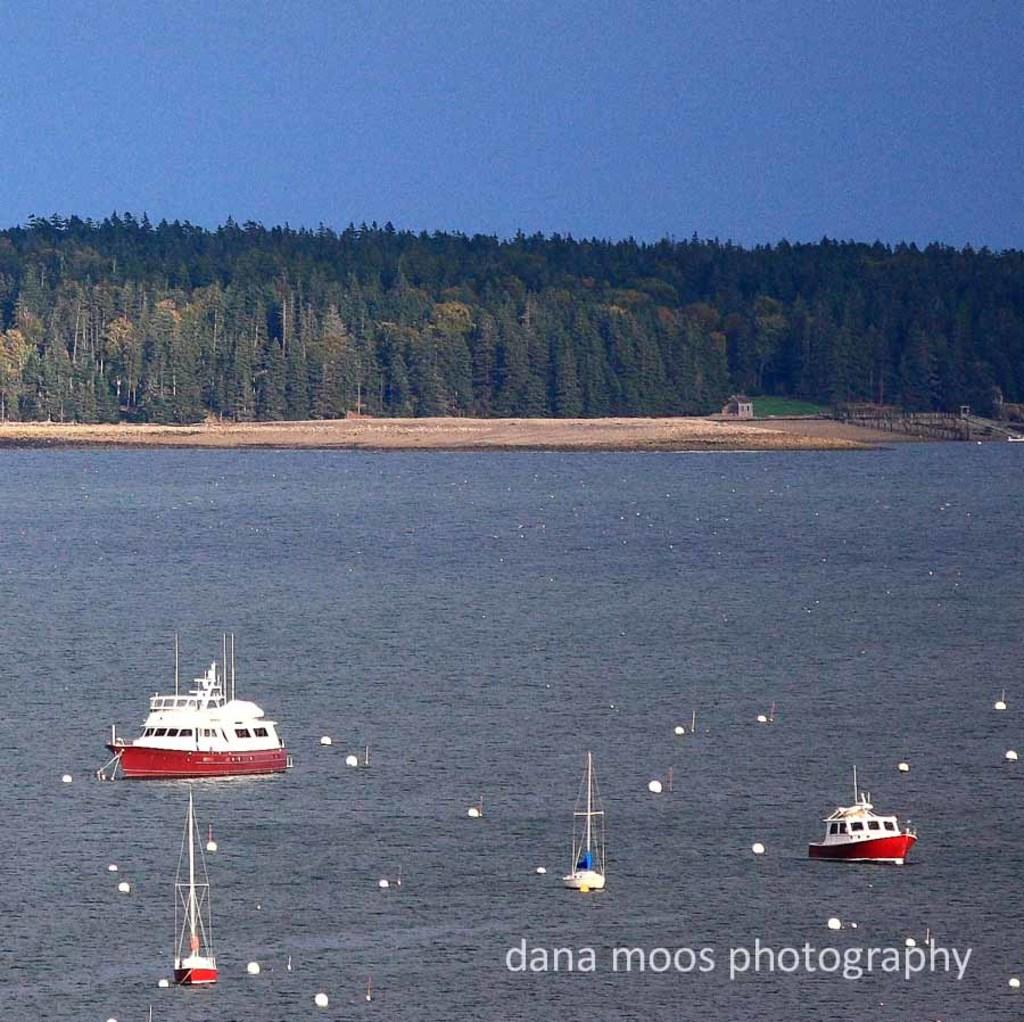<image>
Render a clear and concise summary of the photo. A boat can be seen on the water with a dana moos photography watermark in the corner. 